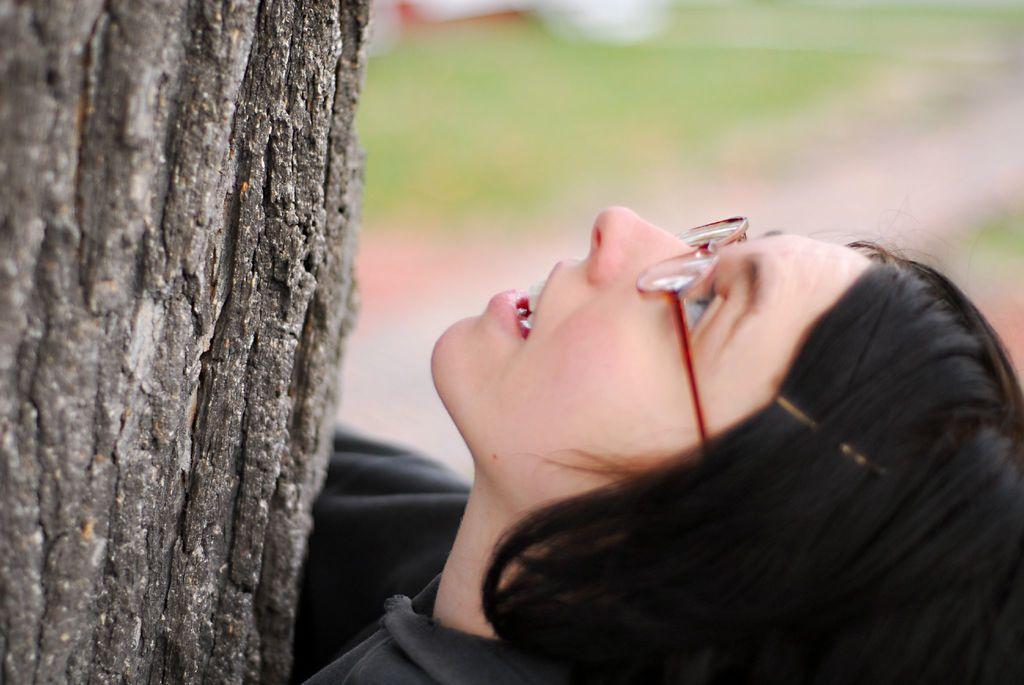Describe this image in one or two sentences. In this image I can see on the left side it is the bark of a tree. On the right side a woman is looking at this side, she wore black color sweater and spectacles 